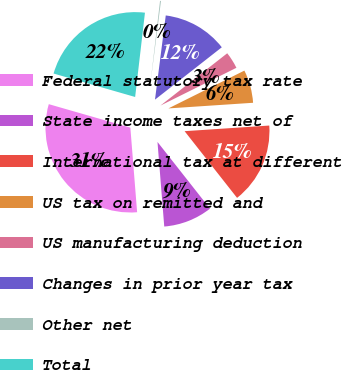<chart> <loc_0><loc_0><loc_500><loc_500><pie_chart><fcel>Federal statutory tax rate<fcel>State income taxes net of<fcel>International tax at different<fcel>US tax on remitted and<fcel>US manufacturing deduction<fcel>Changes in prior year tax<fcel>Other net<fcel>Total<nl><fcel>30.73%<fcel>9.34%<fcel>15.45%<fcel>6.29%<fcel>3.23%<fcel>12.4%<fcel>0.18%<fcel>22.39%<nl></chart> 